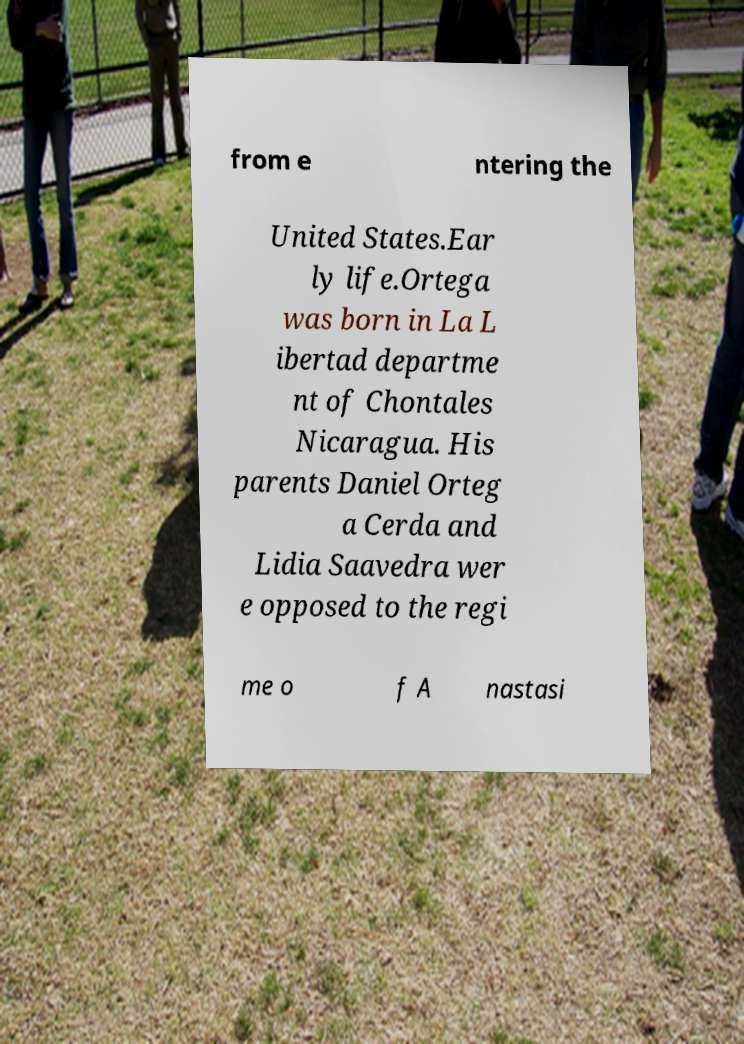Could you extract and type out the text from this image? from e ntering the United States.Ear ly life.Ortega was born in La L ibertad departme nt of Chontales Nicaragua. His parents Daniel Orteg a Cerda and Lidia Saavedra wer e opposed to the regi me o f A nastasi 